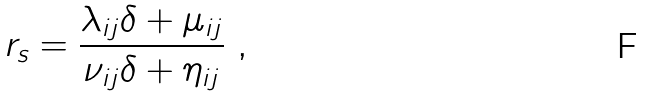<formula> <loc_0><loc_0><loc_500><loc_500>r _ { s } = \frac { \lambda _ { i j } \delta + \mu _ { i j } } { \nu _ { i j } \delta + \eta _ { i j } } \ ,</formula> 